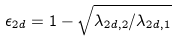<formula> <loc_0><loc_0><loc_500><loc_500>\epsilon _ { 2 d } = 1 - \sqrt { \lambda _ { 2 d , 2 } / \lambda _ { 2 d , 1 } }</formula> 